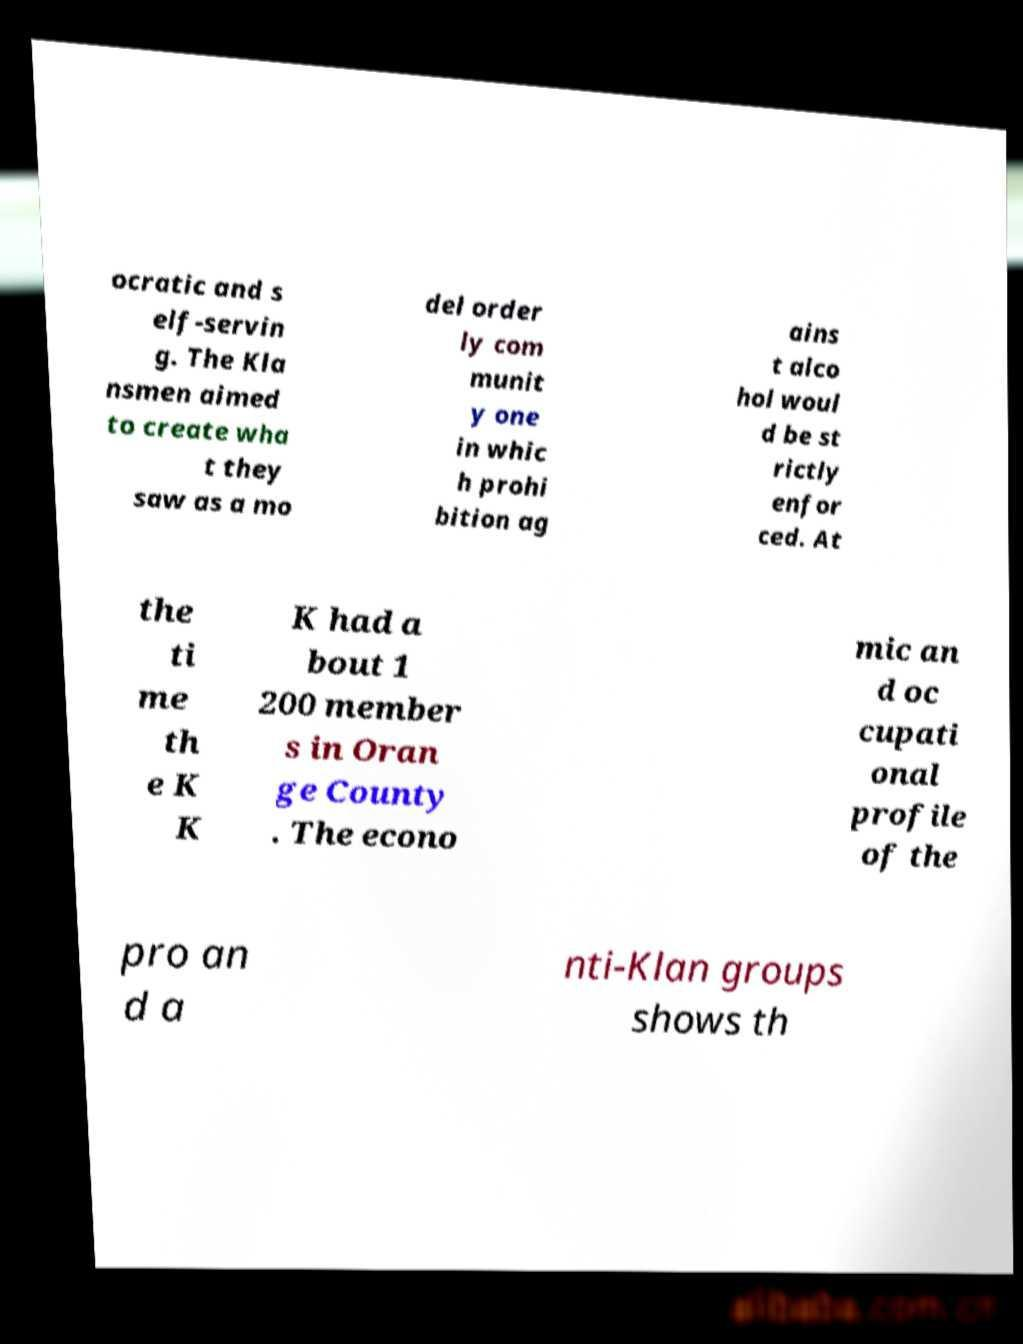Could you assist in decoding the text presented in this image and type it out clearly? ocratic and s elf-servin g. The Kla nsmen aimed to create wha t they saw as a mo del order ly com munit y one in whic h prohi bition ag ains t alco hol woul d be st rictly enfor ced. At the ti me th e K K K had a bout 1 200 member s in Oran ge County . The econo mic an d oc cupati onal profile of the pro an d a nti-Klan groups shows th 